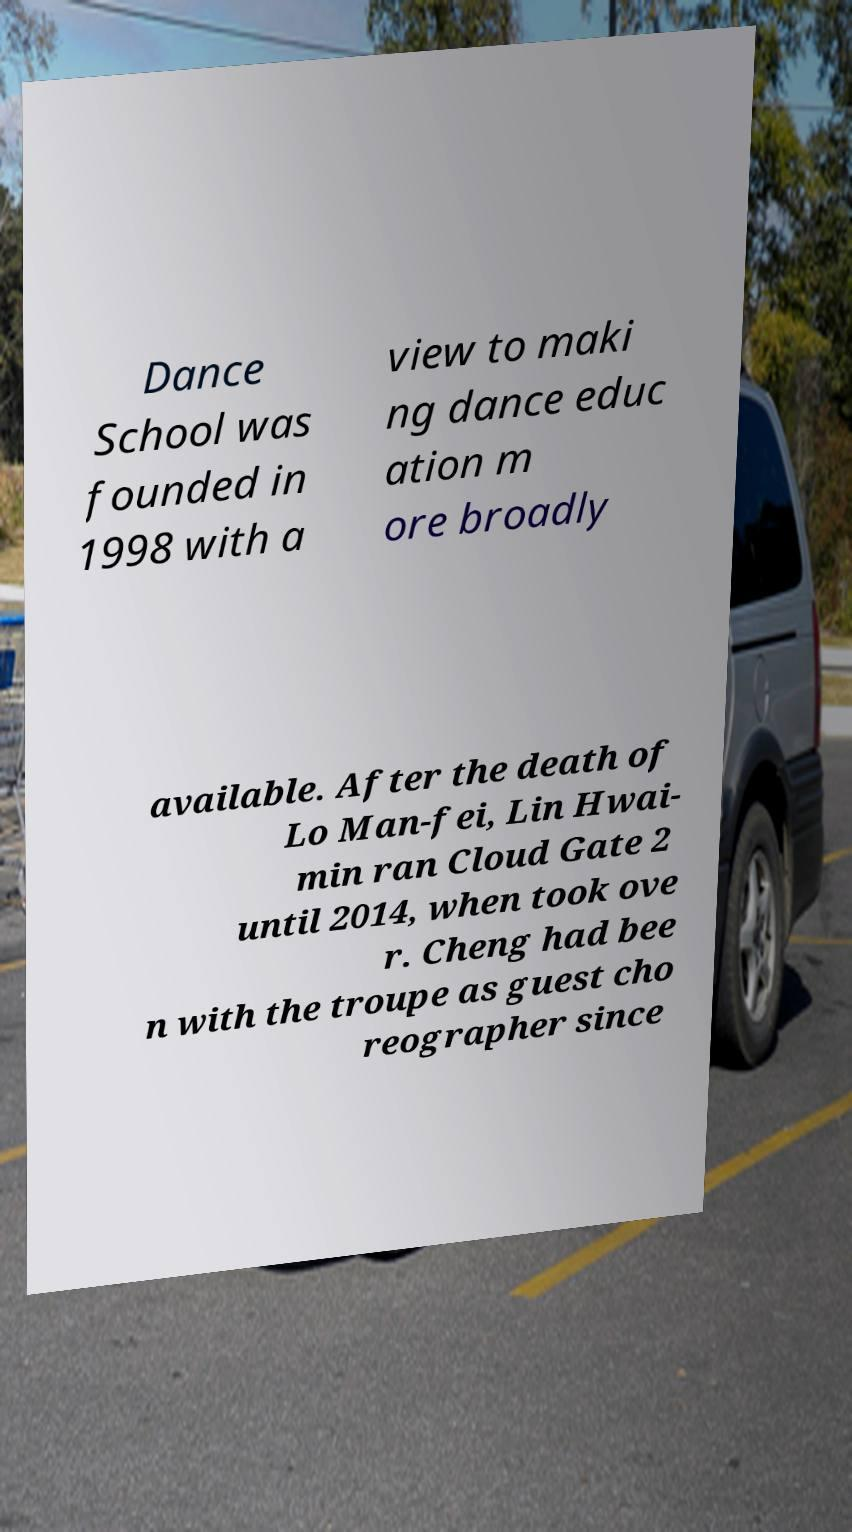Could you extract and type out the text from this image? Dance School was founded in 1998 with a view to maki ng dance educ ation m ore broadly available. After the death of Lo Man-fei, Lin Hwai- min ran Cloud Gate 2 until 2014, when took ove r. Cheng had bee n with the troupe as guest cho reographer since 